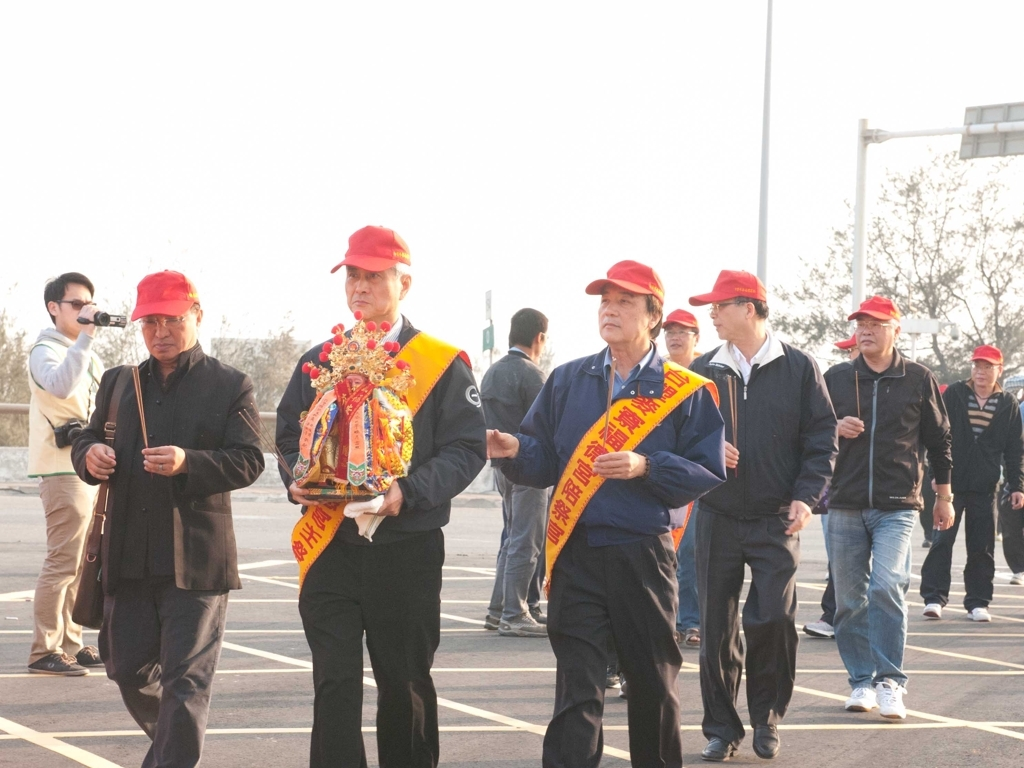Inspect the image closely and offer an evaluation rooted in your analysis.
 The overall clarity of this image is acceptable, with clear details and textures in the main subject. There is minimal noise and rich colors. However, there is some overexposure issue. Therefore, the quality of this image is good. 